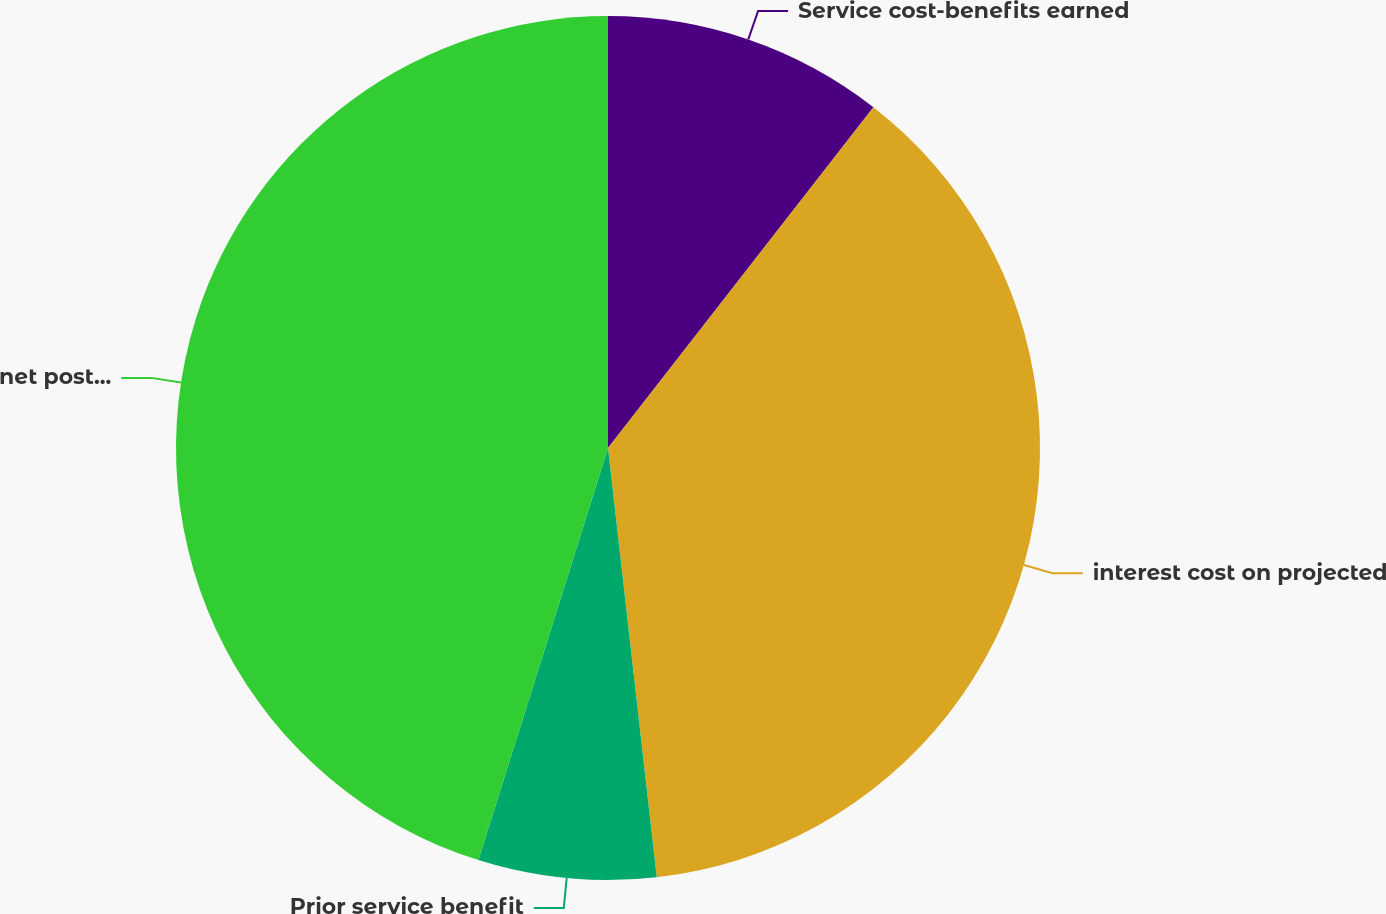Convert chart. <chart><loc_0><loc_0><loc_500><loc_500><pie_chart><fcel>Service cost-benefits earned<fcel>interest cost on projected<fcel>Prior service benefit<fcel>net postretirement benefit<nl><fcel>10.53%<fcel>37.67%<fcel>6.65%<fcel>45.15%<nl></chart> 